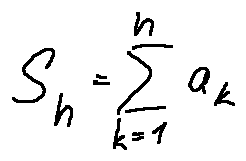<formula> <loc_0><loc_0><loc_500><loc_500>S _ { n } = \sum \lim i t s _ { k = 1 } ^ { n } a _ { k }</formula> 